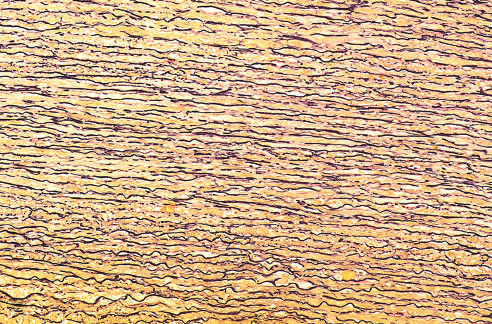did the normal media for comparison show the regular layered pattern of elastic tissue?
Answer the question using a single word or phrase. Yes 